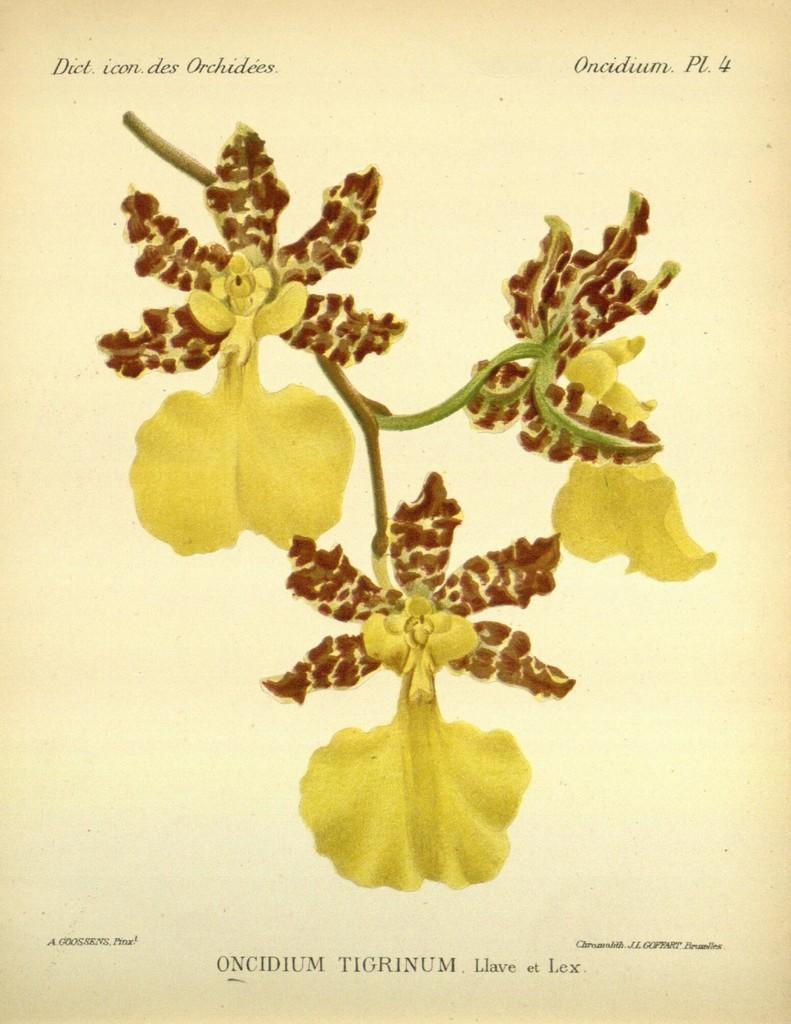<image>
Offer a succinct explanation of the picture presented. a print of an orchid that reads Oncidium Tigrinum 